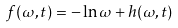<formula> <loc_0><loc_0><loc_500><loc_500>f ( \omega , t ) = - \ln \omega + h ( \omega , t )</formula> 